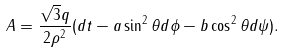<formula> <loc_0><loc_0><loc_500><loc_500>A = \frac { \sqrt { 3 } q } { 2 \rho ^ { 2 } } ( d t - a \sin ^ { 2 } \theta d \phi - b \cos ^ { 2 } \theta d \psi ) .</formula> 